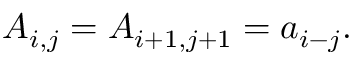<formula> <loc_0><loc_0><loc_500><loc_500>A _ { i , j } = A _ { i + 1 , j + 1 } = a _ { i - j } .</formula> 